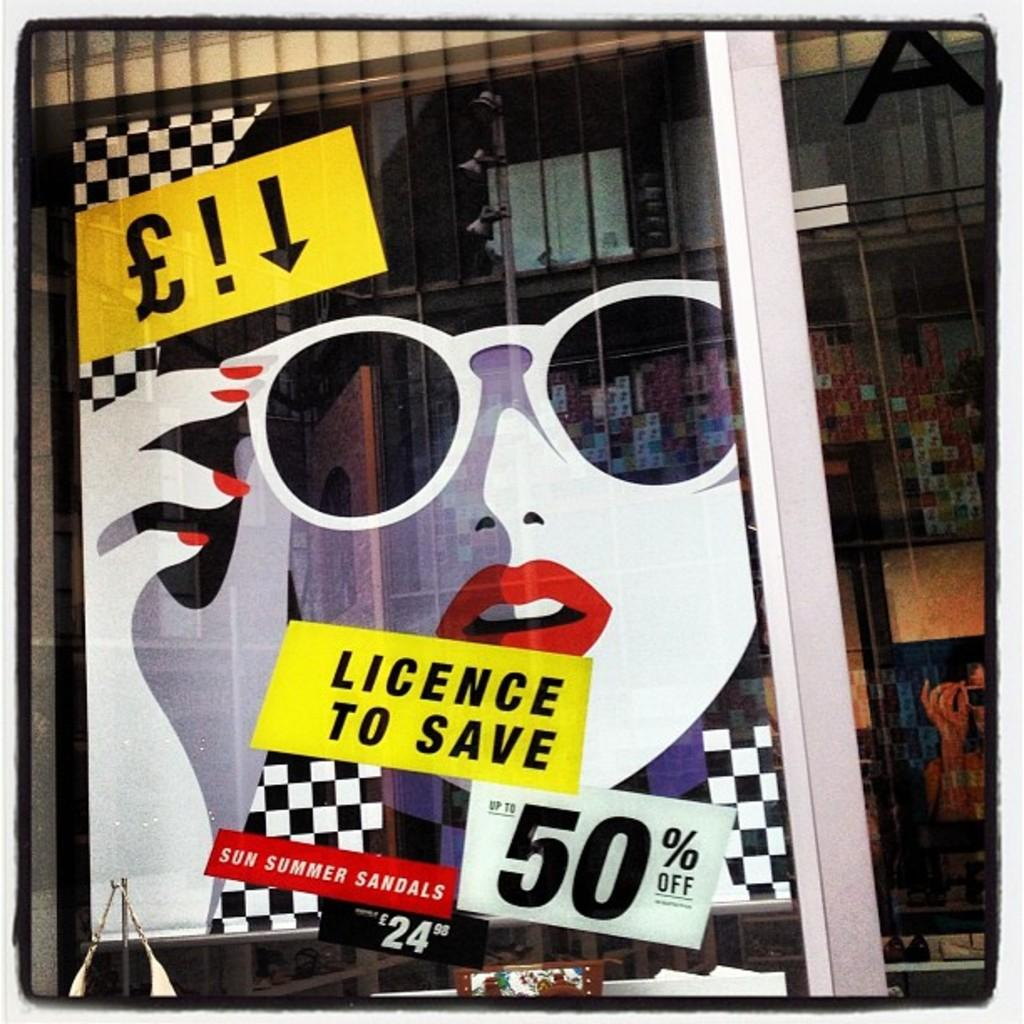What is on the glass door in the image? There are stickers and posters on the glass door. What can be seen through the glass door? Objects are visible through the glass door. What type of writing can be seen on the tiger in the image? There is no tiger or writing present in the image. The image features a glass door with stickers and posters, and nothing else is mentioned. 